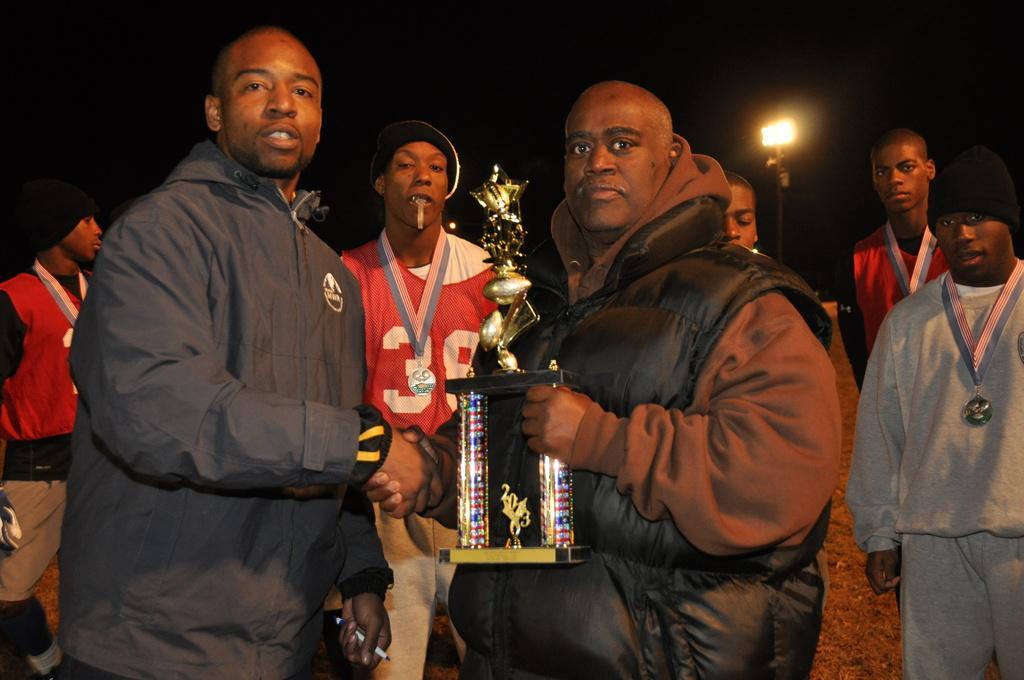Can you describe this image briefly? In this image in the front there are persons standing and shaking hands with each other. On the right side there is a man standing and holding an object in his hand. In the background there are persons standing and there is a wall and there is a light pole. 